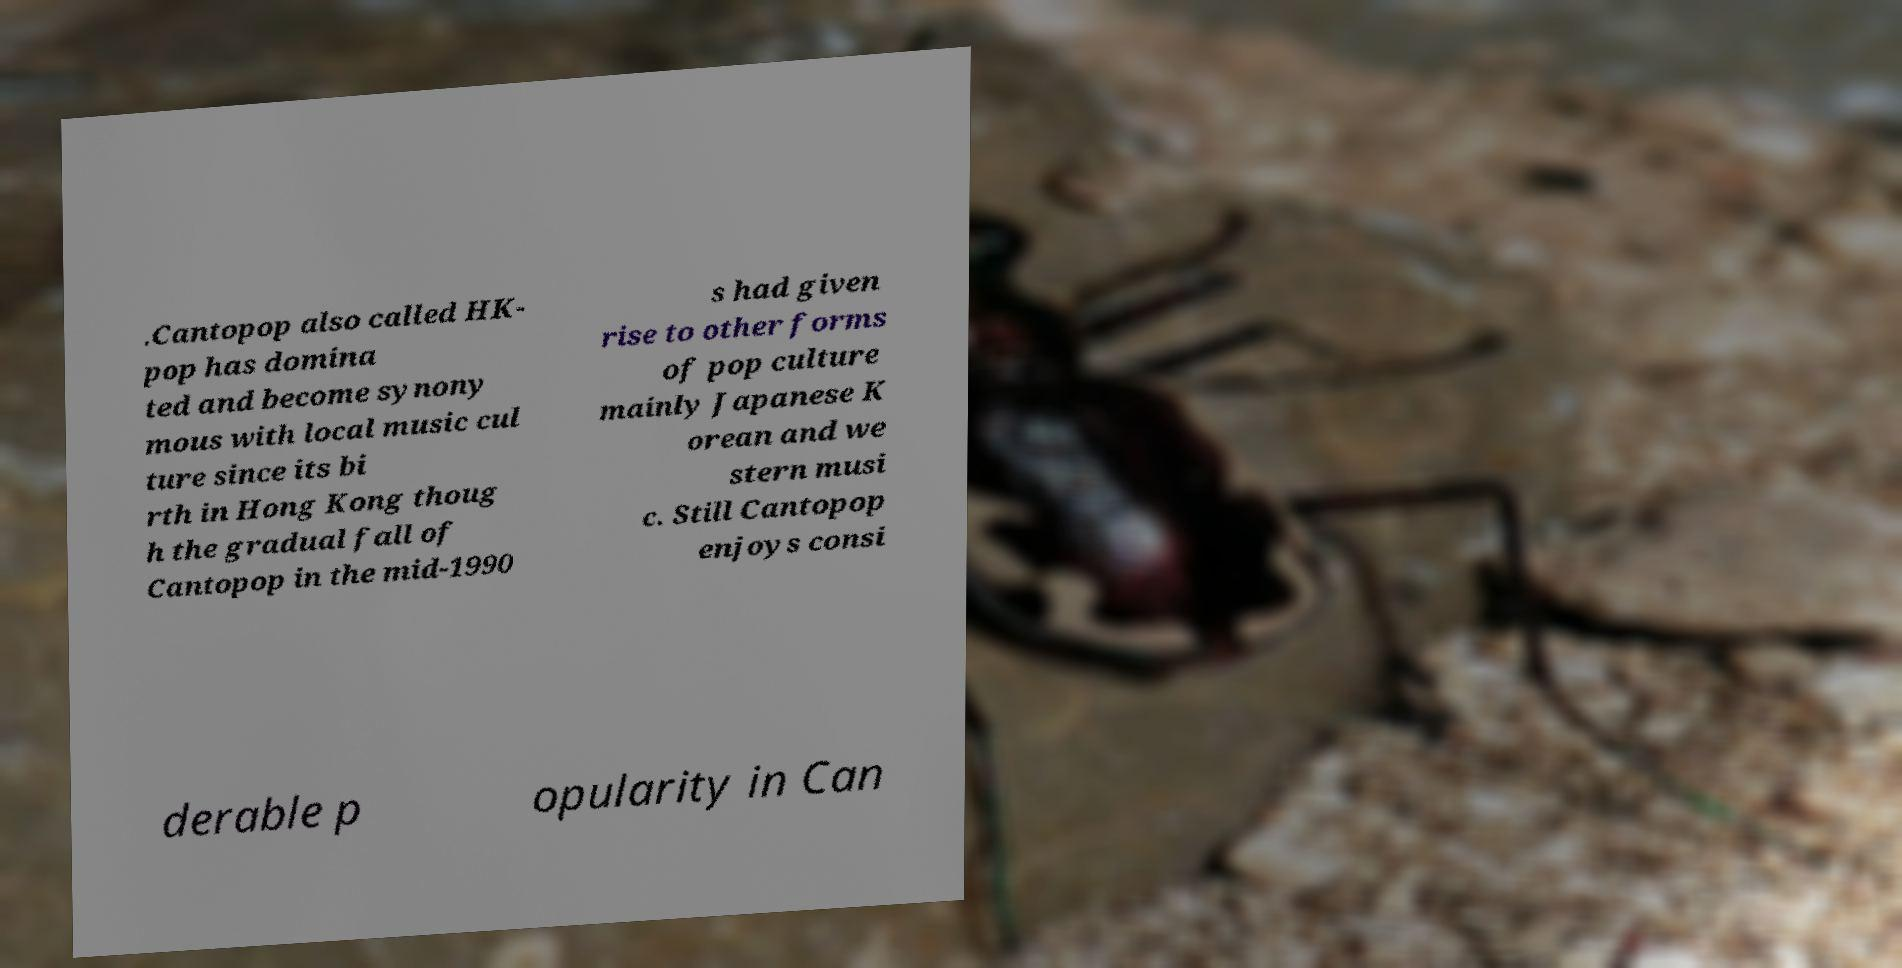Please identify and transcribe the text found in this image. .Cantopop also called HK- pop has domina ted and become synony mous with local music cul ture since its bi rth in Hong Kong thoug h the gradual fall of Cantopop in the mid-1990 s had given rise to other forms of pop culture mainly Japanese K orean and we stern musi c. Still Cantopop enjoys consi derable p opularity in Can 